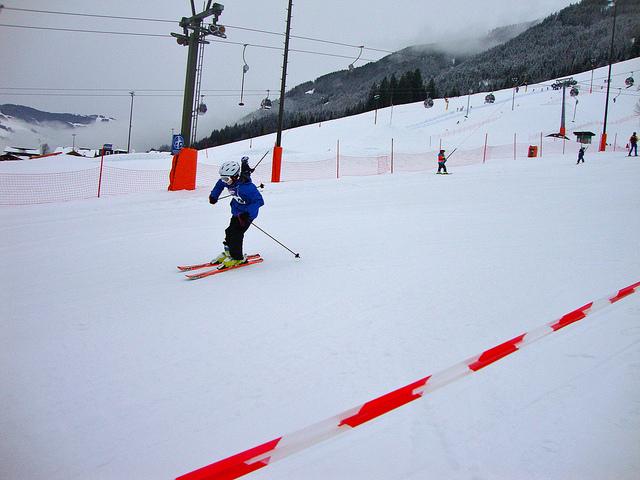What color is the rope?
Concise answer only. Red and white. Are the safety nets needed?
Answer briefly. Yes. How do skiers get up the hill?
Answer briefly. Ski lift. 